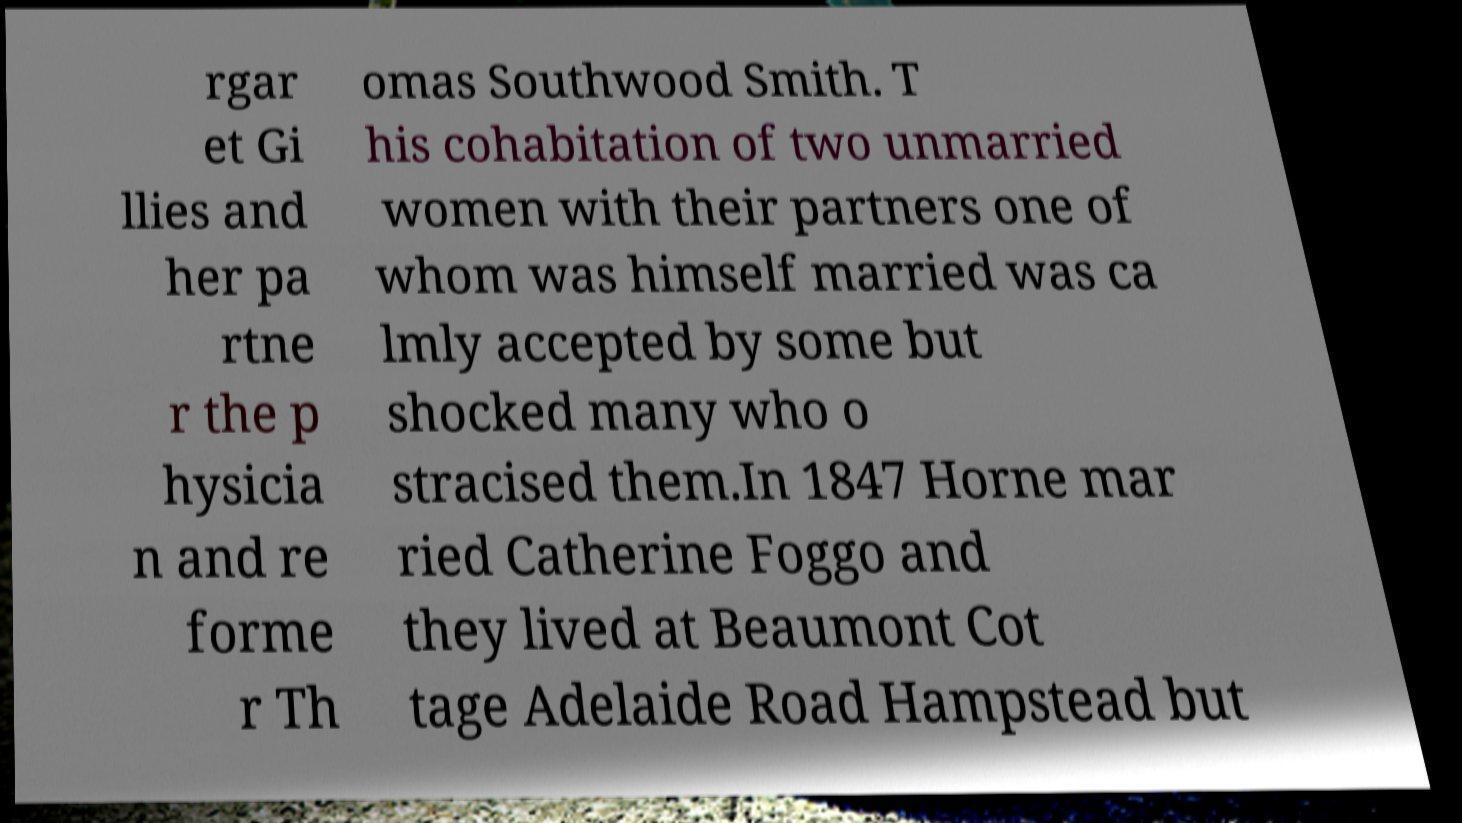Could you assist in decoding the text presented in this image and type it out clearly? rgar et Gi llies and her pa rtne r the p hysicia n and re forme r Th omas Southwood Smith. T his cohabitation of two unmarried women with their partners one of whom was himself married was ca lmly accepted by some but shocked many who o stracised them.In 1847 Horne mar ried Catherine Foggo and they lived at Beaumont Cot tage Adelaide Road Hampstead but 